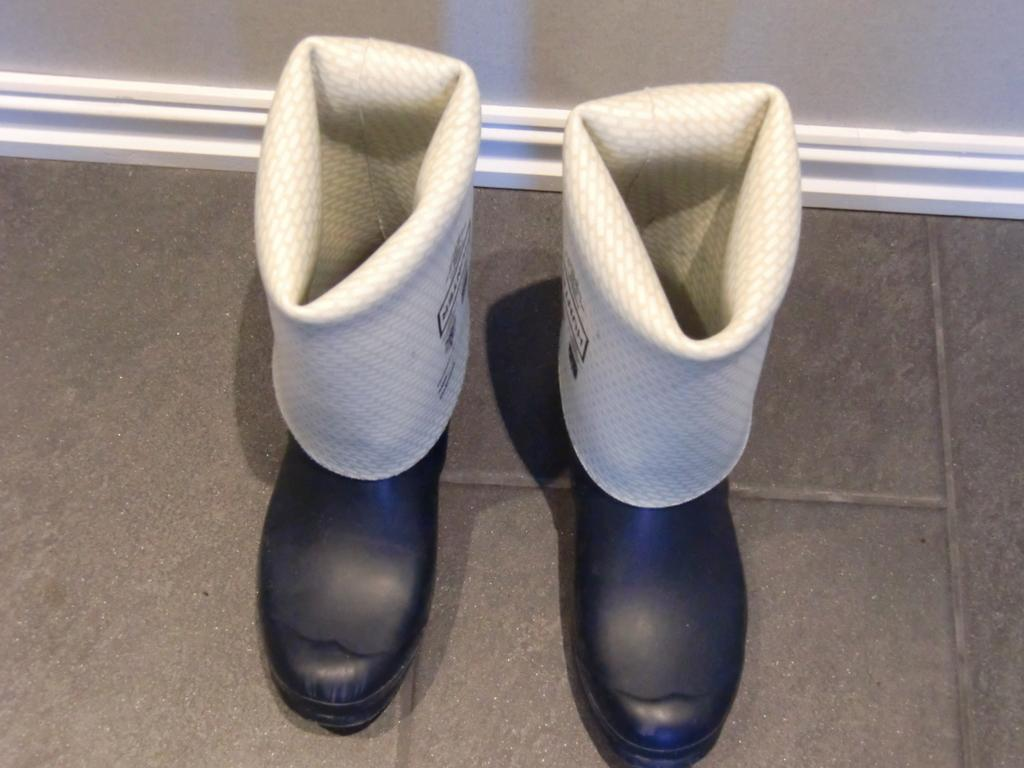What type of footwear is present in the image? There are two boots in the image. Where are the boots located? The boots are on the floor. What can be seen in front of the boots? There is a wall in front of the boots. How many horses are visible in the image? There are no horses present in the image. What type of pets can be seen in the image? There are no pets visible in the image. 